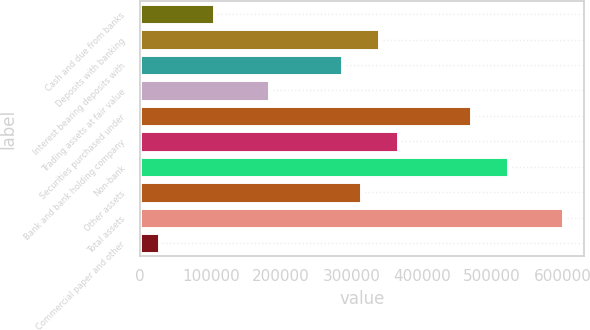Convert chart. <chart><loc_0><loc_0><loc_500><loc_500><bar_chart><fcel>Cash and due from banks<fcel>Deposits with banking<fcel>Interest bearing deposits with<fcel>Trading assets at fair value<fcel>Securities purchased under<fcel>Bank and bank holding company<fcel>Non-bank<fcel>Other assets<fcel>Total assets<fcel>Commercial paper and other<nl><fcel>104466<fcel>339470<fcel>287246<fcel>182800<fcel>470027<fcel>365581<fcel>522250<fcel>313358<fcel>600584<fcel>26131.5<nl></chart> 